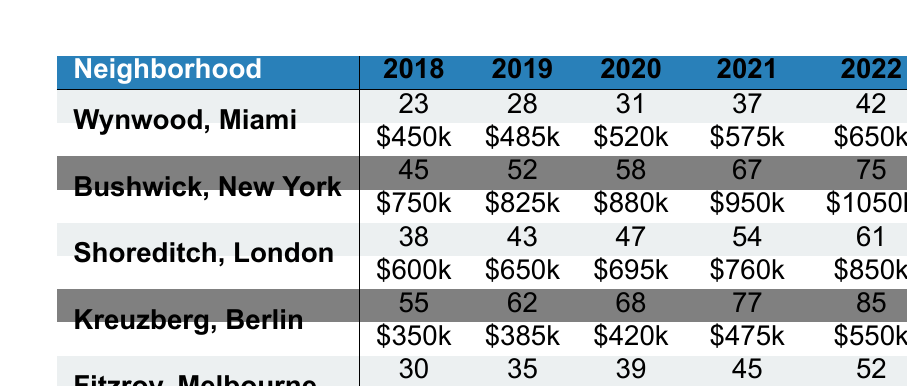What was the average property price in Bushwick, New York in 2020? The average property price in Bushwick for 2020 is listed as $880,000.
Answer: $880,000 How many street art installations were there in Shoreditch, London in 2019? The table shows that Shoreditch had 43 street art installations in 2019.
Answer: 43 Which neighborhood had the highest average property price in 2022? By looking at the values for 2022, Bushwick had the highest average property price at $1,050,000.
Answer: Bushwick What was the increase in average property price from 2018 to 2022 in Wynwood, Miami? The average property price in Wynwood in 2018 was $450,000 and in 2022 it was $650,000. The increase is $650,000 - $450,000 = $200,000.
Answer: $200,000 Did Kreuzberg, Berlin have more street art installations than Fitzroy, Melbourne in 2021? In 2021, Kreuzberg had 77 street art installations, while Fitzroy had 45. Therefore, Kreuzberg did have more installations.
Answer: Yes What is the total number of street art installations in Fitzroy, Melbourne from 2018 to 2022? The total is calculated as 30 + 35 + 39 + 45 + 52 = 201 street art installations from 2018 to 2022.
Answer: 201 Between 2018 and 2022, which neighborhood saw the largest percentage increase in average property price? The average property price in Fitzroy increased from $800,000 in 2018 to $1,150,000 in 2022. The percentage increase is ((1,150,000 - 800,000) / 800,000) * 100 = 43.75%. The other neighborhoods show lower percentage increases, indicating Fitzroy had the largest increase.
Answer: Fitzroy What were the average property prices for Kreuzberg, Berlin in 2019 and 2022? The average property price in Kreuzberg for 2019 is $385,000, and for 2022 it is $550,000.
Answer: $385,000 (2019), $550,000 (2022) How many street art installations were there in Bushwick, New York in 2020 compared to Miami? In Bushwick, there were 58 installations in 2020, while in Miami, there were 31 installations. Thus, Bushwick had 58 - 31 = 27 more installations than Miami.
Answer: 27 more Did the average property price in Shoreditch, London exceed $700,000 in 2020? The average property price in Shoreditch in 2020 was $695,000, which did not exceed $700,000.
Answer: No 